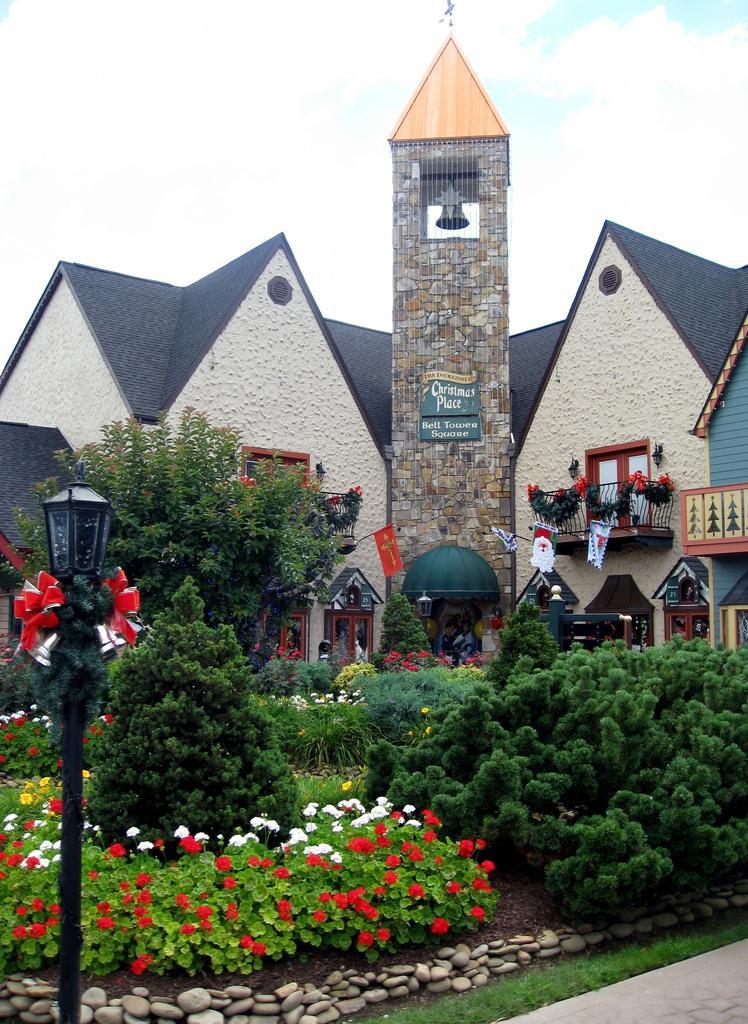Please provide a concise description of this image. In this picture we can see the buildings, bell, boards on the wall, balconies, pots, plants, flowers, tree, pole, light. At the bottom of the image we can see the grass, stones and ground. At the top of the image we can see the sky. 